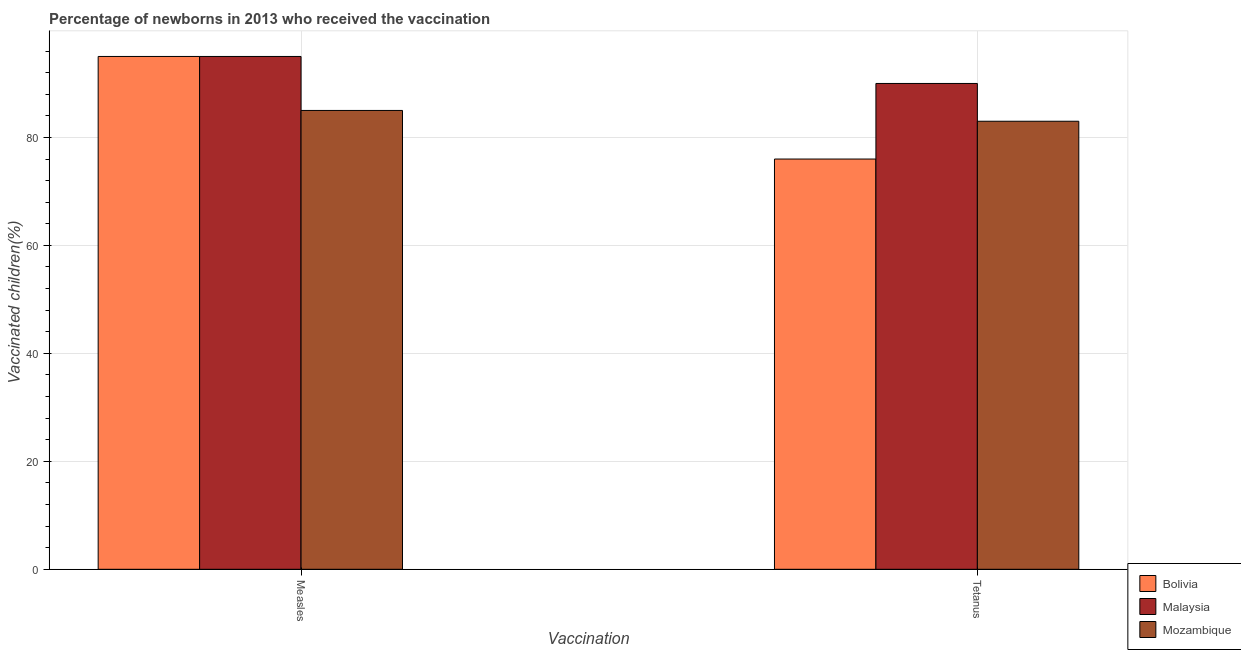How many different coloured bars are there?
Make the answer very short. 3. How many groups of bars are there?
Your answer should be compact. 2. Are the number of bars per tick equal to the number of legend labels?
Your answer should be compact. Yes. Are the number of bars on each tick of the X-axis equal?
Give a very brief answer. Yes. What is the label of the 2nd group of bars from the left?
Keep it short and to the point. Tetanus. What is the percentage of newborns who received vaccination for tetanus in Mozambique?
Make the answer very short. 83. Across all countries, what is the maximum percentage of newborns who received vaccination for measles?
Offer a terse response. 95. Across all countries, what is the minimum percentage of newborns who received vaccination for measles?
Provide a short and direct response. 85. What is the total percentage of newborns who received vaccination for measles in the graph?
Give a very brief answer. 275. What is the difference between the percentage of newborns who received vaccination for tetanus in Mozambique and that in Malaysia?
Offer a very short reply. -7. What is the difference between the percentage of newborns who received vaccination for tetanus in Malaysia and the percentage of newborns who received vaccination for measles in Mozambique?
Give a very brief answer. 5. What is the average percentage of newborns who received vaccination for tetanus per country?
Keep it short and to the point. 83. What is the difference between the percentage of newborns who received vaccination for measles and percentage of newborns who received vaccination for tetanus in Bolivia?
Provide a succinct answer. 19. What is the ratio of the percentage of newborns who received vaccination for tetanus in Bolivia to that in Mozambique?
Ensure brevity in your answer.  0.92. Is the percentage of newborns who received vaccination for tetanus in Malaysia less than that in Bolivia?
Give a very brief answer. No. What does the 3rd bar from the right in Tetanus represents?
Give a very brief answer. Bolivia. How many bars are there?
Keep it short and to the point. 6. How many countries are there in the graph?
Offer a very short reply. 3. What is the difference between two consecutive major ticks on the Y-axis?
Ensure brevity in your answer.  20. Are the values on the major ticks of Y-axis written in scientific E-notation?
Your answer should be compact. No. Does the graph contain any zero values?
Provide a succinct answer. No. How many legend labels are there?
Your response must be concise. 3. How are the legend labels stacked?
Make the answer very short. Vertical. What is the title of the graph?
Your answer should be compact. Percentage of newborns in 2013 who received the vaccination. What is the label or title of the X-axis?
Ensure brevity in your answer.  Vaccination. What is the label or title of the Y-axis?
Offer a terse response. Vaccinated children(%)
. What is the Vaccinated children(%)
 of Bolivia in Measles?
Keep it short and to the point. 95. Across all Vaccination, what is the maximum Vaccinated children(%)
 of Bolivia?
Ensure brevity in your answer.  95. Across all Vaccination, what is the minimum Vaccinated children(%)
 of Bolivia?
Keep it short and to the point. 76. Across all Vaccination, what is the minimum Vaccinated children(%)
 in Malaysia?
Give a very brief answer. 90. Across all Vaccination, what is the minimum Vaccinated children(%)
 in Mozambique?
Your answer should be very brief. 83. What is the total Vaccinated children(%)
 of Bolivia in the graph?
Ensure brevity in your answer.  171. What is the total Vaccinated children(%)
 in Malaysia in the graph?
Provide a short and direct response. 185. What is the total Vaccinated children(%)
 of Mozambique in the graph?
Make the answer very short. 168. What is the difference between the Vaccinated children(%)
 of Bolivia in Measles and the Vaccinated children(%)
 of Malaysia in Tetanus?
Provide a short and direct response. 5. What is the difference between the Vaccinated children(%)
 of Malaysia in Measles and the Vaccinated children(%)
 of Mozambique in Tetanus?
Give a very brief answer. 12. What is the average Vaccinated children(%)
 in Bolivia per Vaccination?
Offer a very short reply. 85.5. What is the average Vaccinated children(%)
 in Malaysia per Vaccination?
Your response must be concise. 92.5. What is the average Vaccinated children(%)
 in Mozambique per Vaccination?
Provide a succinct answer. 84. What is the difference between the Vaccinated children(%)
 of Malaysia and Vaccinated children(%)
 of Mozambique in Measles?
Keep it short and to the point. 10. What is the difference between the Vaccinated children(%)
 of Bolivia and Vaccinated children(%)
 of Malaysia in Tetanus?
Offer a terse response. -14. What is the ratio of the Vaccinated children(%)
 in Malaysia in Measles to that in Tetanus?
Your answer should be compact. 1.06. What is the ratio of the Vaccinated children(%)
 of Mozambique in Measles to that in Tetanus?
Your response must be concise. 1.02. What is the difference between the highest and the second highest Vaccinated children(%)
 of Mozambique?
Provide a succinct answer. 2. What is the difference between the highest and the lowest Vaccinated children(%)
 in Bolivia?
Your answer should be very brief. 19. What is the difference between the highest and the lowest Vaccinated children(%)
 of Malaysia?
Your answer should be compact. 5. What is the difference between the highest and the lowest Vaccinated children(%)
 of Mozambique?
Offer a very short reply. 2. 